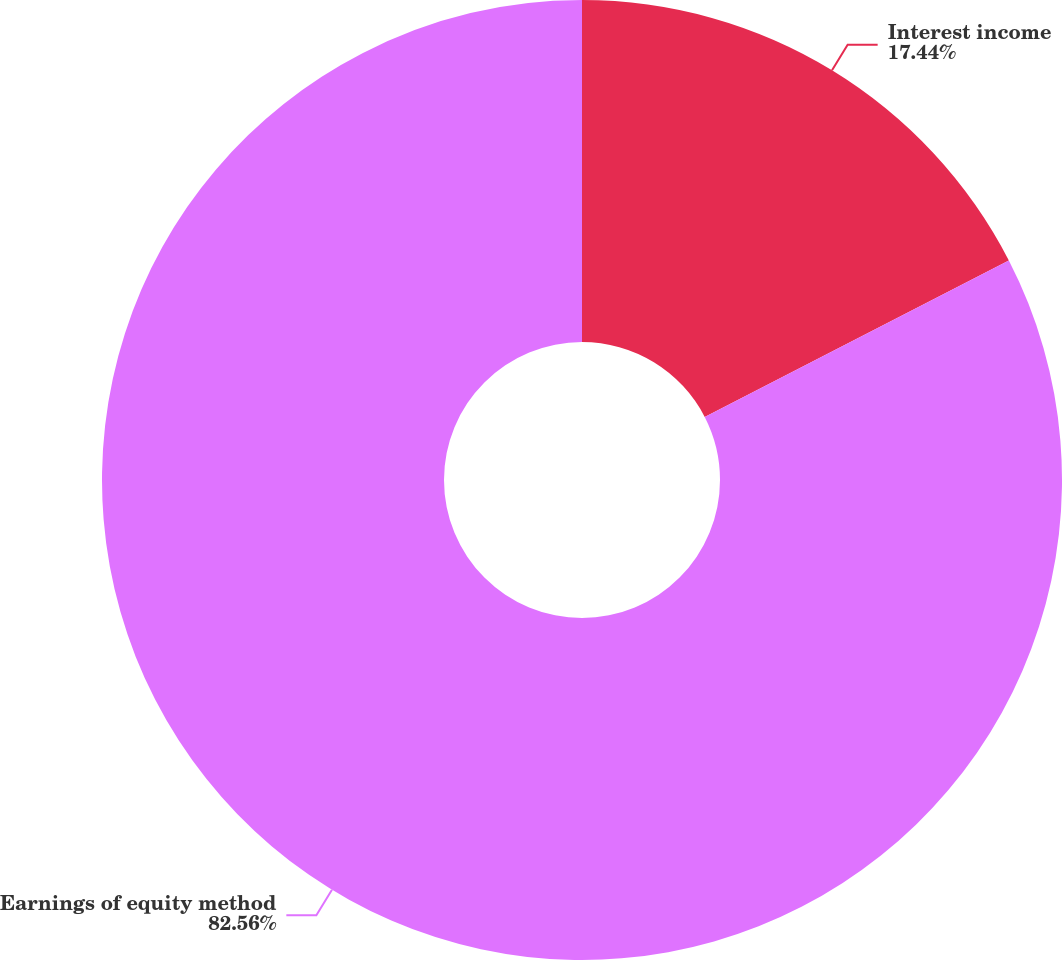Convert chart to OTSL. <chart><loc_0><loc_0><loc_500><loc_500><pie_chart><fcel>Interest income<fcel>Earnings of equity method<nl><fcel>17.44%<fcel>82.56%<nl></chart> 